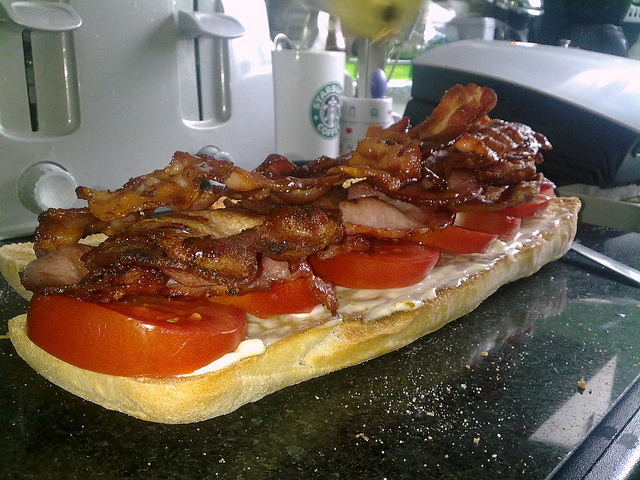If this sandwich could talk, what would it say? If this sandwich could talk, it might exclaim, 'I'm the ultimate combination of crunchy, savory, and juicy! Just wait until you take a bite and experience the perfect blend of crispy bacon, fresh tomatoes, and luscious mayo. I'm here to make your taste buds dance with joy!' Describe a scenario where this sandwich might be the star of the show. Picture this: It's a sunny Saturday morning, and you're hosting a casual brunch for friends in your cozy kitchen. As your guests chat and sip their coffee, you unveil this magnificent sandwich as the centerpiece of the meal. The sun streams through the window, illuminating the vibrant colors of the tomatoes and the glistening, crispy bacon. Your friends' eyes widen in anticipation as you slice the sandwich into generous portions, each bite promising the perfect balance of flavors and textures. This sandwich isn't just food; it's an experience—a delightful, communal moment that brings everyone together.  Imagine this sandwich in a fantastical world. What's its story? In a fantastical world where food reigns supreme, this sandwich would be known as the 'Majestic BLT of Comfortia.' Crafted by the legendary Chef Crunchelot, it is said that the sandwich holds magical powers capable of bringing joy to anyone who takes a bite. The tomatoes are plucked from the enchanted gardens of Juicyvale, and the bacon comes from the woodland creatures who willingly contribute to the sustenance of the realm. The bread, baked with golden flour from the rolling fields of Doughshire, has a crust that sings when cut. The Majestic BLT of Comfortia is not just a sandwich; it's a symbol of unity and delight, revered across the land. 